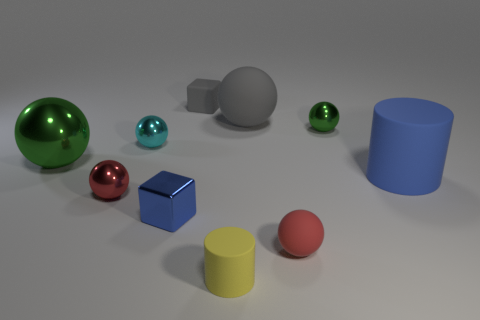Are there any tiny red things that have the same material as the small green ball?
Provide a short and direct response. Yes. There is a thing that is the same color as the large metallic sphere; what is its shape?
Make the answer very short. Sphere. How many tiny brown metallic cubes are there?
Provide a succinct answer. 0. What number of cubes are either green things or large gray objects?
Ensure brevity in your answer.  0. The rubber cube that is the same size as the yellow matte cylinder is what color?
Your response must be concise. Gray. What number of rubber objects are both to the right of the tiny gray rubber object and behind the small cyan object?
Offer a terse response. 1. What is the material of the tiny cyan object?
Keep it short and to the point. Metal. What number of things are either blue matte cylinders or big green things?
Your answer should be very brief. 2. Does the metallic object that is to the right of the red matte ball have the same size as the blue thing that is in front of the large blue thing?
Ensure brevity in your answer.  Yes. What number of other things are there of the same size as the yellow object?
Your answer should be very brief. 6. 